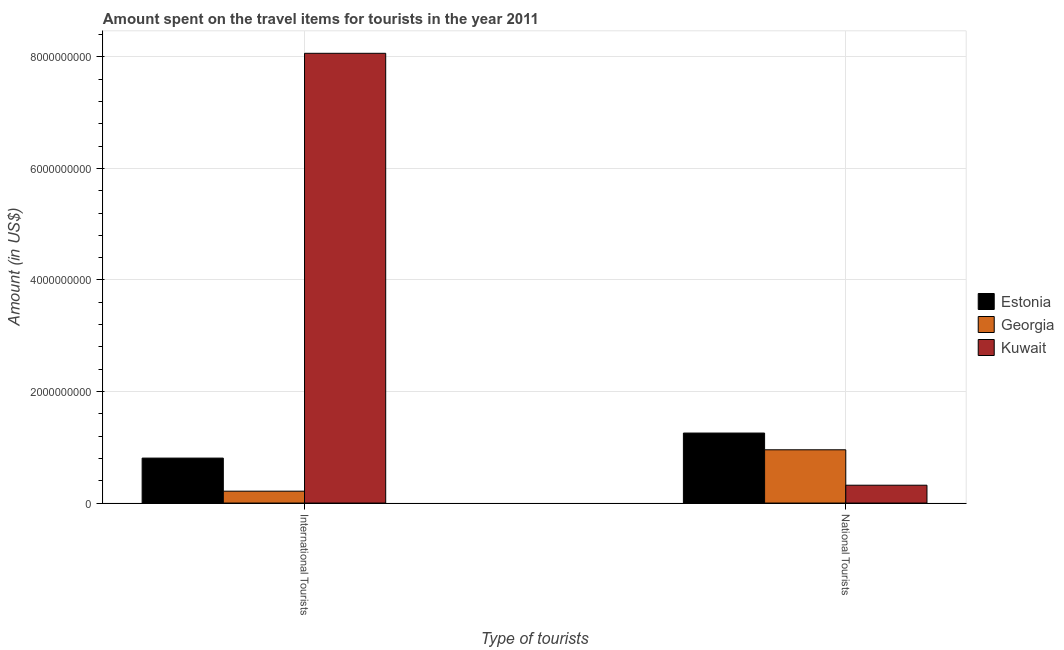How many different coloured bars are there?
Offer a terse response. 3. How many groups of bars are there?
Offer a very short reply. 2. Are the number of bars per tick equal to the number of legend labels?
Make the answer very short. Yes. Are the number of bars on each tick of the X-axis equal?
Your answer should be compact. Yes. What is the label of the 2nd group of bars from the left?
Offer a terse response. National Tourists. What is the amount spent on travel items of international tourists in Estonia?
Provide a short and direct response. 8.06e+08. Across all countries, what is the maximum amount spent on travel items of national tourists?
Ensure brevity in your answer.  1.26e+09. Across all countries, what is the minimum amount spent on travel items of international tourists?
Provide a short and direct response. 2.13e+08. In which country was the amount spent on travel items of international tourists maximum?
Ensure brevity in your answer.  Kuwait. In which country was the amount spent on travel items of international tourists minimum?
Give a very brief answer. Georgia. What is the total amount spent on travel items of national tourists in the graph?
Offer a very short reply. 2.53e+09. What is the difference between the amount spent on travel items of international tourists in Kuwait and that in Estonia?
Provide a succinct answer. 7.26e+09. What is the difference between the amount spent on travel items of international tourists in Georgia and the amount spent on travel items of national tourists in Estonia?
Your response must be concise. -1.04e+09. What is the average amount spent on travel items of international tourists per country?
Ensure brevity in your answer.  3.03e+09. What is the difference between the amount spent on travel items of national tourists and amount spent on travel items of international tourists in Estonia?
Your answer should be compact. 4.49e+08. What is the ratio of the amount spent on travel items of national tourists in Estonia to that in Kuwait?
Keep it short and to the point. 3.92. Is the amount spent on travel items of international tourists in Georgia less than that in Kuwait?
Make the answer very short. Yes. In how many countries, is the amount spent on travel items of national tourists greater than the average amount spent on travel items of national tourists taken over all countries?
Your answer should be very brief. 2. What does the 2nd bar from the left in National Tourists represents?
Your answer should be very brief. Georgia. What does the 2nd bar from the right in International Tourists represents?
Your answer should be very brief. Georgia. How many bars are there?
Give a very brief answer. 6. Are all the bars in the graph horizontal?
Offer a very short reply. No. What is the difference between two consecutive major ticks on the Y-axis?
Your answer should be compact. 2.00e+09. Are the values on the major ticks of Y-axis written in scientific E-notation?
Your answer should be very brief. No. Does the graph contain any zero values?
Offer a terse response. No. Where does the legend appear in the graph?
Your response must be concise. Center right. How are the legend labels stacked?
Provide a short and direct response. Vertical. What is the title of the graph?
Make the answer very short. Amount spent on the travel items for tourists in the year 2011. What is the label or title of the X-axis?
Provide a succinct answer. Type of tourists. What is the label or title of the Y-axis?
Make the answer very short. Amount (in US$). What is the Amount (in US$) in Estonia in International Tourists?
Make the answer very short. 8.06e+08. What is the Amount (in US$) in Georgia in International Tourists?
Provide a succinct answer. 2.13e+08. What is the Amount (in US$) of Kuwait in International Tourists?
Provide a short and direct response. 8.06e+09. What is the Amount (in US$) of Estonia in National Tourists?
Offer a terse response. 1.26e+09. What is the Amount (in US$) in Georgia in National Tourists?
Keep it short and to the point. 9.55e+08. What is the Amount (in US$) in Kuwait in National Tourists?
Keep it short and to the point. 3.20e+08. Across all Type of tourists, what is the maximum Amount (in US$) of Estonia?
Your answer should be compact. 1.26e+09. Across all Type of tourists, what is the maximum Amount (in US$) of Georgia?
Offer a terse response. 9.55e+08. Across all Type of tourists, what is the maximum Amount (in US$) in Kuwait?
Keep it short and to the point. 8.06e+09. Across all Type of tourists, what is the minimum Amount (in US$) of Estonia?
Keep it short and to the point. 8.06e+08. Across all Type of tourists, what is the minimum Amount (in US$) in Georgia?
Provide a succinct answer. 2.13e+08. Across all Type of tourists, what is the minimum Amount (in US$) of Kuwait?
Offer a very short reply. 3.20e+08. What is the total Amount (in US$) in Estonia in the graph?
Provide a succinct answer. 2.06e+09. What is the total Amount (in US$) in Georgia in the graph?
Your answer should be compact. 1.17e+09. What is the total Amount (in US$) of Kuwait in the graph?
Provide a succinct answer. 8.38e+09. What is the difference between the Amount (in US$) in Estonia in International Tourists and that in National Tourists?
Provide a short and direct response. -4.49e+08. What is the difference between the Amount (in US$) in Georgia in International Tourists and that in National Tourists?
Make the answer very short. -7.42e+08. What is the difference between the Amount (in US$) in Kuwait in International Tourists and that in National Tourists?
Provide a succinct answer. 7.74e+09. What is the difference between the Amount (in US$) in Estonia in International Tourists and the Amount (in US$) in Georgia in National Tourists?
Give a very brief answer. -1.49e+08. What is the difference between the Amount (in US$) in Estonia in International Tourists and the Amount (in US$) in Kuwait in National Tourists?
Your answer should be very brief. 4.86e+08. What is the difference between the Amount (in US$) in Georgia in International Tourists and the Amount (in US$) in Kuwait in National Tourists?
Offer a terse response. -1.07e+08. What is the average Amount (in US$) in Estonia per Type of tourists?
Provide a short and direct response. 1.03e+09. What is the average Amount (in US$) of Georgia per Type of tourists?
Give a very brief answer. 5.84e+08. What is the average Amount (in US$) in Kuwait per Type of tourists?
Make the answer very short. 4.19e+09. What is the difference between the Amount (in US$) in Estonia and Amount (in US$) in Georgia in International Tourists?
Provide a succinct answer. 5.93e+08. What is the difference between the Amount (in US$) in Estonia and Amount (in US$) in Kuwait in International Tourists?
Give a very brief answer. -7.26e+09. What is the difference between the Amount (in US$) in Georgia and Amount (in US$) in Kuwait in International Tourists?
Your answer should be very brief. -7.85e+09. What is the difference between the Amount (in US$) in Estonia and Amount (in US$) in Georgia in National Tourists?
Provide a succinct answer. 3.00e+08. What is the difference between the Amount (in US$) in Estonia and Amount (in US$) in Kuwait in National Tourists?
Keep it short and to the point. 9.35e+08. What is the difference between the Amount (in US$) in Georgia and Amount (in US$) in Kuwait in National Tourists?
Make the answer very short. 6.35e+08. What is the ratio of the Amount (in US$) in Estonia in International Tourists to that in National Tourists?
Give a very brief answer. 0.64. What is the ratio of the Amount (in US$) in Georgia in International Tourists to that in National Tourists?
Ensure brevity in your answer.  0.22. What is the ratio of the Amount (in US$) of Kuwait in International Tourists to that in National Tourists?
Make the answer very short. 25.2. What is the difference between the highest and the second highest Amount (in US$) of Estonia?
Offer a terse response. 4.49e+08. What is the difference between the highest and the second highest Amount (in US$) of Georgia?
Your answer should be compact. 7.42e+08. What is the difference between the highest and the second highest Amount (in US$) of Kuwait?
Your response must be concise. 7.74e+09. What is the difference between the highest and the lowest Amount (in US$) of Estonia?
Give a very brief answer. 4.49e+08. What is the difference between the highest and the lowest Amount (in US$) in Georgia?
Keep it short and to the point. 7.42e+08. What is the difference between the highest and the lowest Amount (in US$) of Kuwait?
Your answer should be compact. 7.74e+09. 